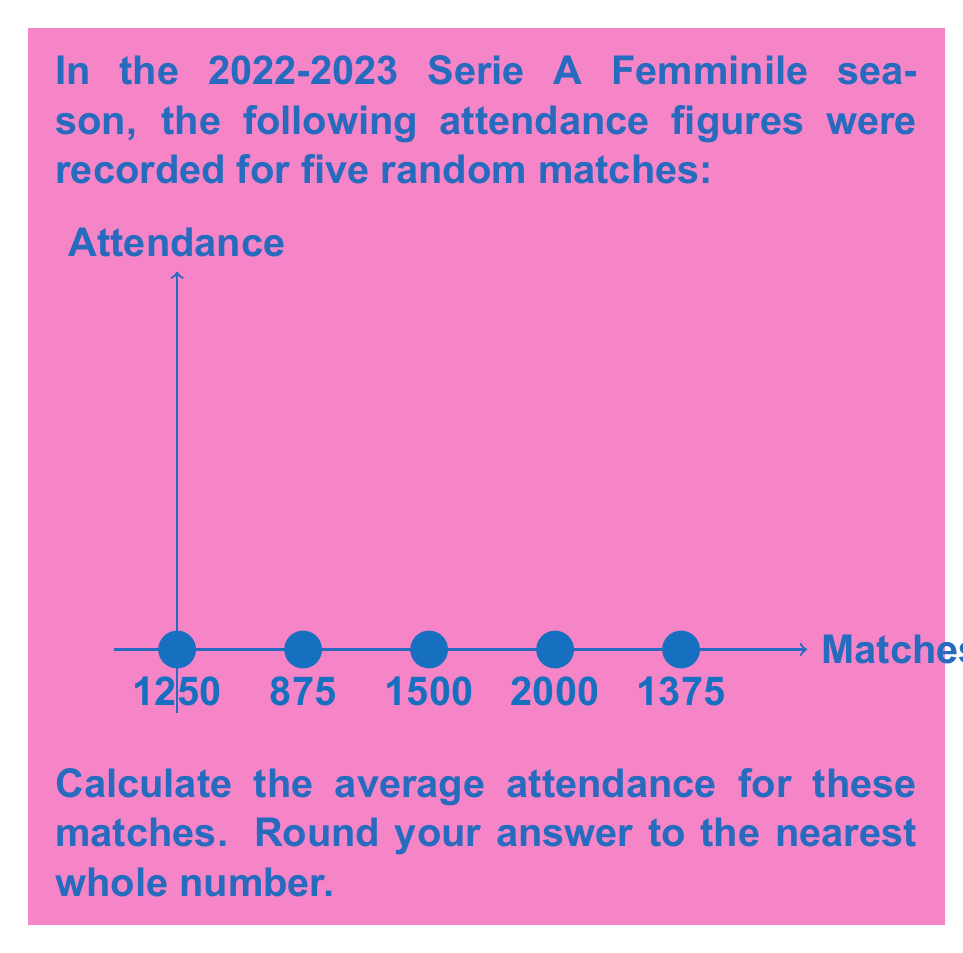Give your solution to this math problem. To calculate the average attendance, we need to follow these steps:

1. Sum up all the attendance figures:
   $$1250 + 875 + 1500 + 2000 + 1375 = 7000$$

2. Count the total number of matches:
   There are 5 matches in total.

3. Divide the sum by the number of matches:
   $$\text{Average} = \frac{\text{Sum of attendances}}{\text{Number of matches}} = \frac{7000}{5} = 1400$$

4. Round to the nearest whole number:
   1400 is already a whole number, so no rounding is necessary.

Therefore, the average attendance for these women's football matches in Italy is 1400 spectators.
Answer: 1400 spectators 